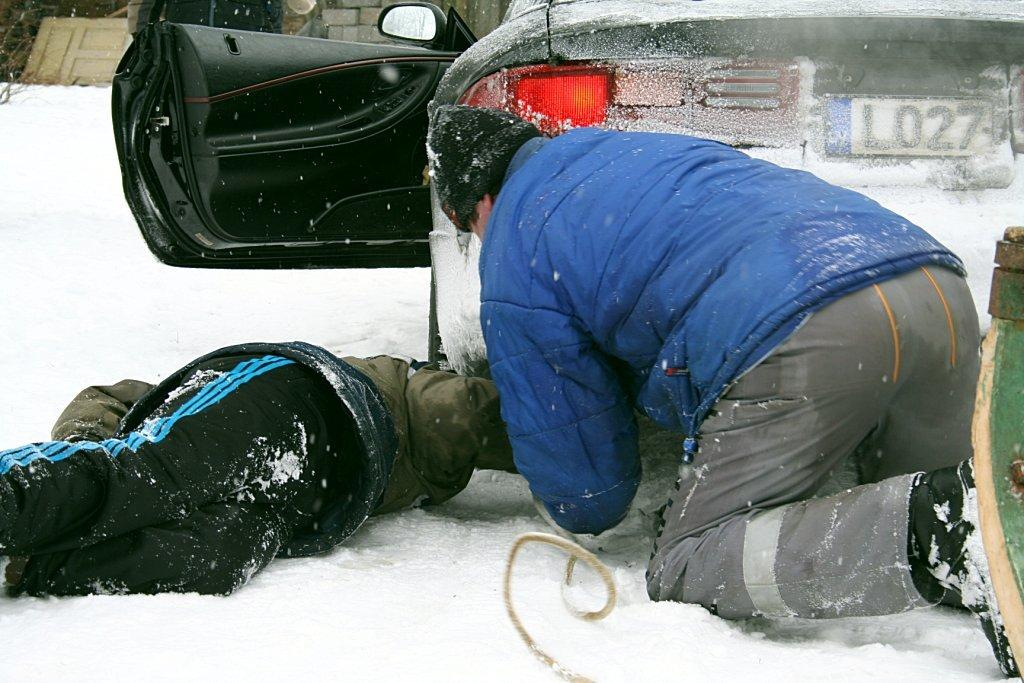How many people are in the foreground of the image? There are two people in the foreground of the image. What can be seen in the image besides the people? There is a car, snow, a door, and other objects visible in the background of the image. What is the condition of the ground in the image? The ground is covered in snow at the bottom of the image. What is the purpose of the door visible in the background? The purpose of the door is not clear from the image, but it is likely an entrance to a building or structure. What type of reaction can be seen on the tongue of the person in the image? There is no tongue visible in the image, so it is not possible to determine any reactions. 